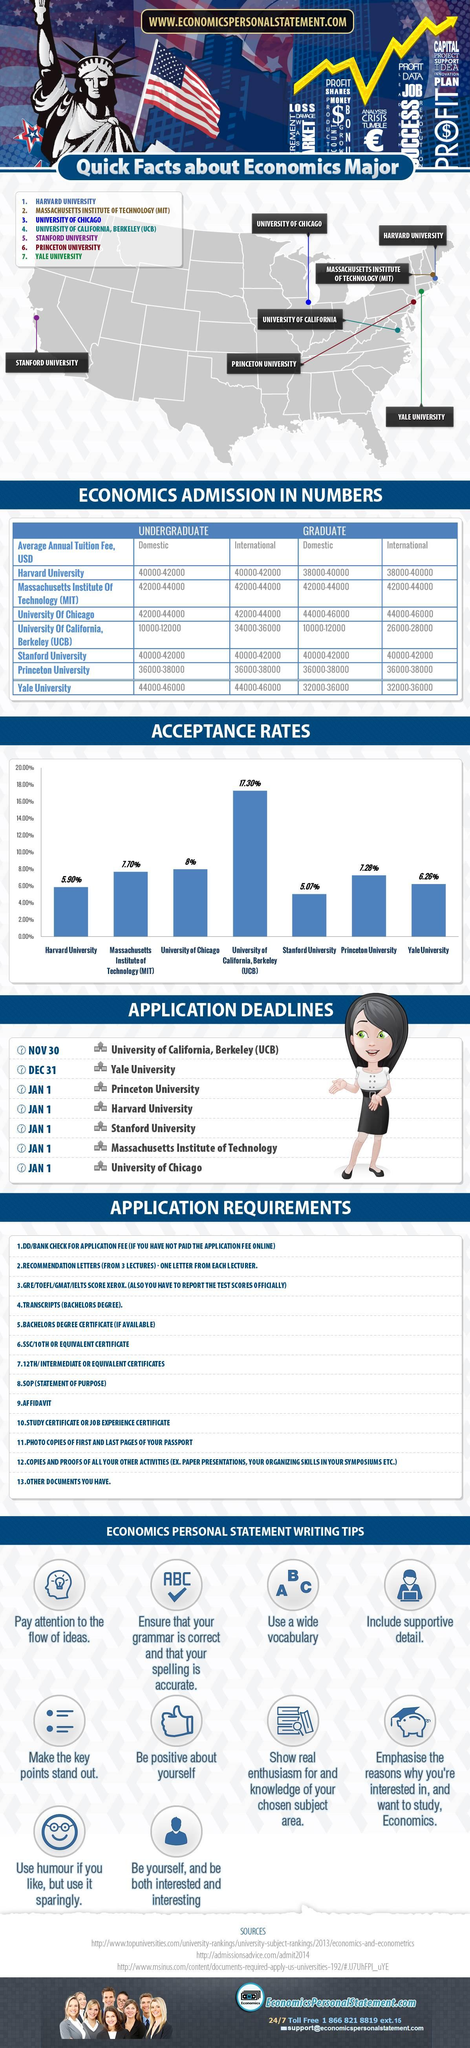Specify some key components in this picture. Stanford University has the lowest application acceptance rate among all universities in the United States. The average annual tuition fee for undergraduate studies at the University of Chicago for domestic students falls within a range of 42,000 to 44,000 USD. The University of Chicago's application acceptance rate is 8%. University of California, Berkeley (UCB) has the highest application acceptance rate in the U.S. The application acceptance rate at Yale University is 6.26%. 